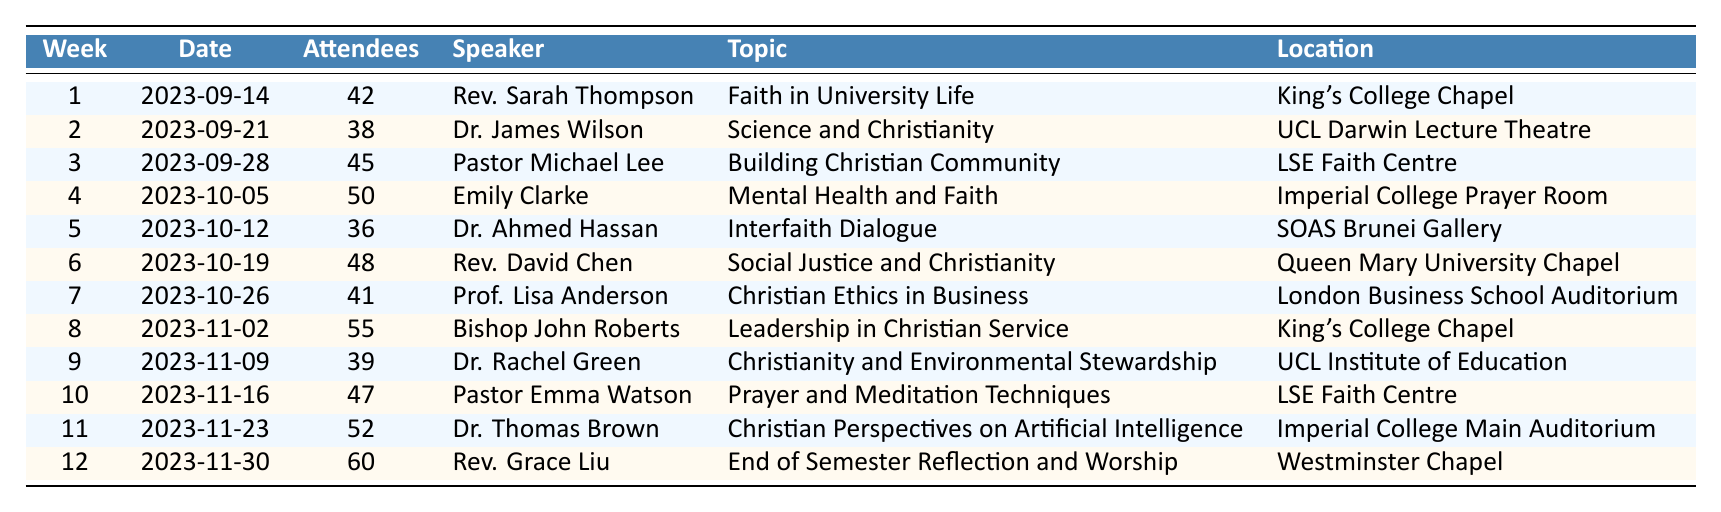What was the highest attendance in a week? The table shows weekly attendance records, with the highest number of attendees indicated in the "Attendees" column for week 12 (60 attendees).
Answer: 60 Who was the speaker for the topic "Mental Health and Faith"? Looking at the "Topic" column, "Mental Health and Faith" corresponds to week 4, which lists Emily Clarke as the speaker in the "Speaker" column.
Answer: Emily Clarke How many attendees were there in total over 12 weeks? To find the total, we sum the "Attendees" column: 42 + 38 + 45 + 50 + 36 + 48 + 41 + 55 + 39 + 47 + 52 + 60 =  462.
Answer: 462 Did Rev. Grace Liu speak on the same topic twice? Reviewing the "Speaker" column, Rev. Grace Liu only appears once at week 12, meaning she has not spoken on the same topic multiple times.
Answer: No What was the average attendance for weeks 5 to 8? The attendance for weeks 5 to 8 is 36, 48, 41, and 55 respectively. Calculate the total as 36 + 48 + 41 + 55 = 180, and then find the average by dividing by 4, which gives us 180 / 4 = 45.
Answer: 45 Which location had the highest attendance? Analyzing the "Location" column along with the attendance figures, the location with the highest attendance (60) is Westminster Chapel during week 12.
Answer: Westminster Chapel What was the attendance difference between the week with the highest and lowest attendance? The highest attendance is 60 (week 12), and the lowest is 36 (week 5). The difference is 60 - 36 = 24.
Answer: 24 How many speakers talked about themes related to "Christianity"? From the "Topic" column, themes like "Science and Christianity", "Christian Community", "Christian Ethics in Business", etc., all relate to Christianity. Counting these topics results in 9 related themes.
Answer: 9 Was there any week with more than 50 attendees? Reviewing the attendance numbers, weeks 8 (55), 11 (52), and 12 (60) all had more than 50 attendees, confirming there were weeks with attendance exceeding that number.
Answer: Yes How many speakers were female? In the "Speaker" column, the female speakers include Rev. Sarah Thompson, Emily Clarke, Bishop John Roberts, Dr. Rachel Green, and Rev. Grace Liu, resulting in a total of 5 female speakers.
Answer: 5 